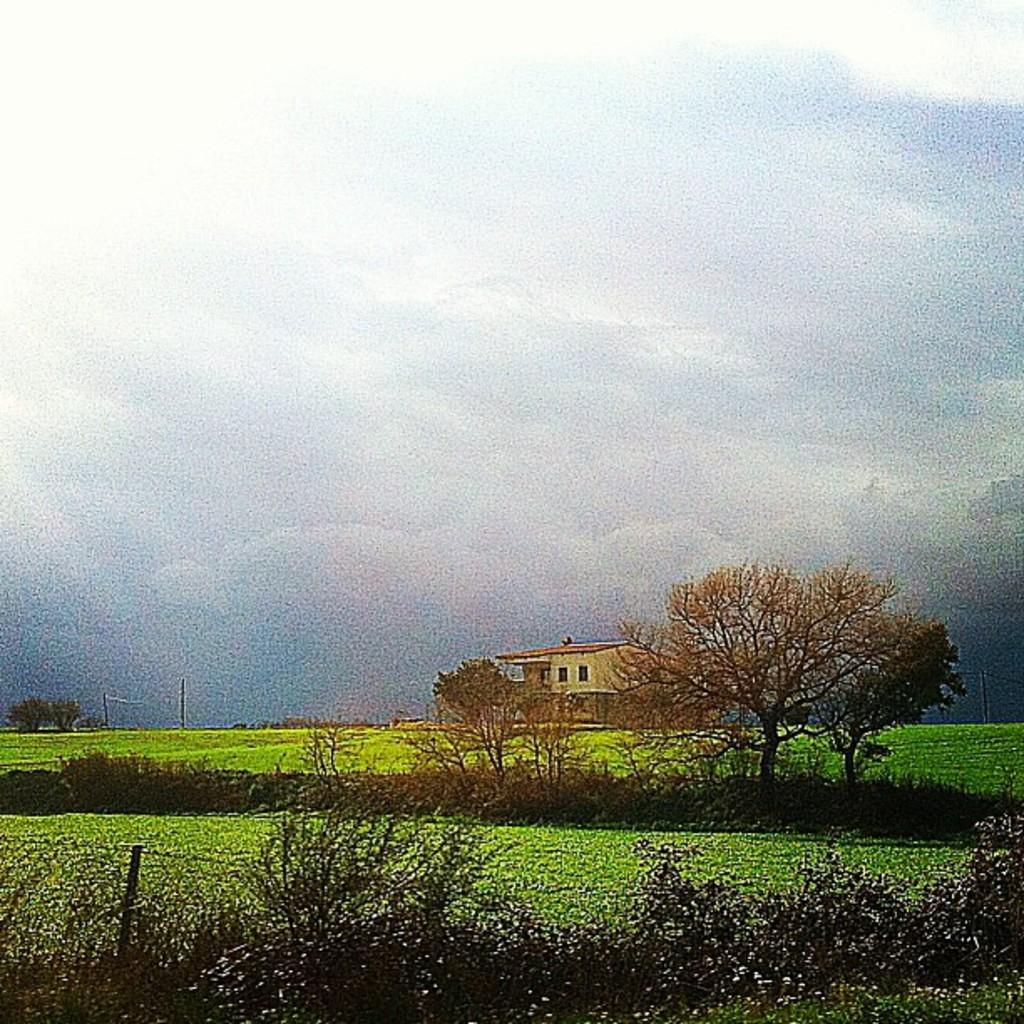What type of vegetation or plants can be seen at the bottom side of the image? There is greenery at the bottom side of the image. What structure is located in the center of the image? There is a house in the center of the image. What is visible at the top side of the image? There is sky at the top side of the image. What color of paint is used on the key in the image? There is no key present in the image, so it is not possible to determine the color of paint on it. How does the greenery show respect in the image? The greenery does not show respect in the image; it is simply a part of the landscape. 